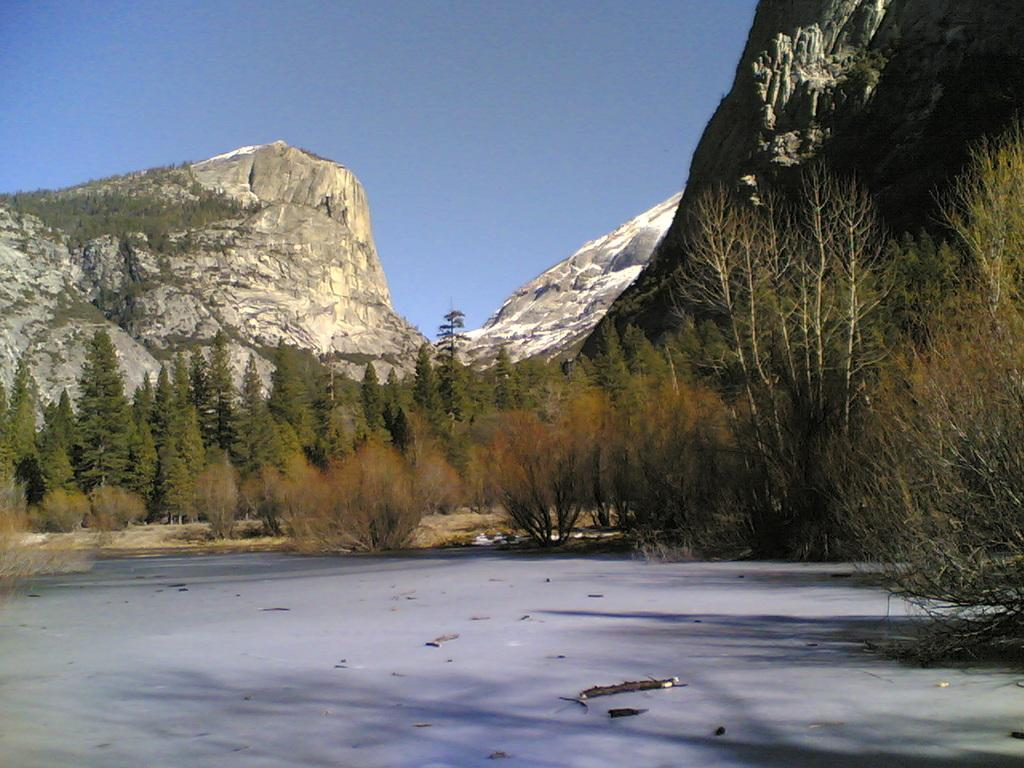What type of terrain is visible in the image? There is land visible in the image. What natural features can be seen around the land? There are trees around the land. What other objects can be seen on the land? There are rocks visible in the image. What type of pies are being served for breakfast in the image? There is no mention of pies or breakfast in the image; it only features land, trees, and rocks. 